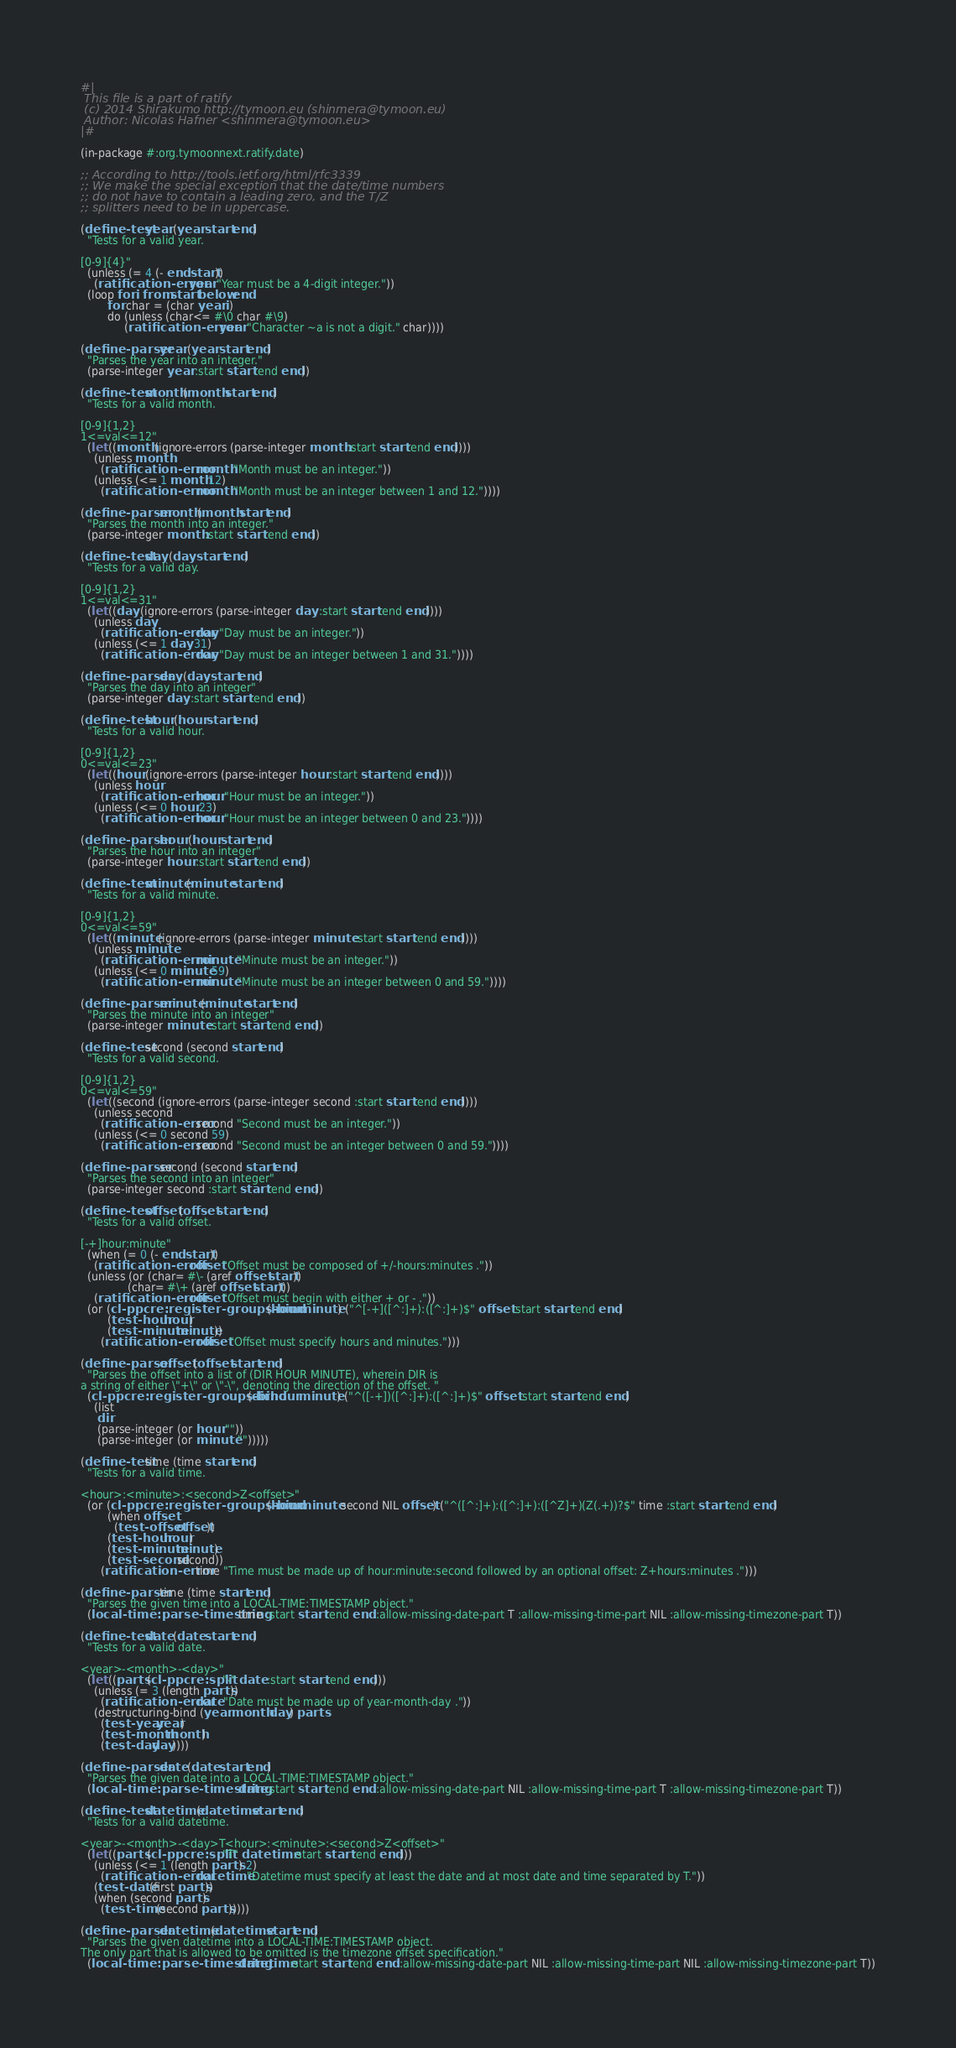Convert code to text. <code><loc_0><loc_0><loc_500><loc_500><_Lisp_>#|
 This file is a part of ratify
 (c) 2014 Shirakumo http://tymoon.eu (shinmera@tymoon.eu)
 Author: Nicolas Hafner <shinmera@tymoon.eu>
|#

(in-package #:org.tymoonnext.ratify.date)

;; According to http://tools.ietf.org/html/rfc3339
;; We make the special exception that the date/time numbers
;; do not have to contain a leading zero, and the T/Z
;; splitters need to be in uppercase.

(define-test year (year start end)
  "Tests for a valid year. 

[0-9]{4}"
  (unless (= 4 (- end start))
    (ratification-error year "Year must be a 4-digit integer."))
  (loop for i from start below end
        for char = (char year i)
        do (unless (char<= #\0 char #\9)
             (ratification-error year "Character ~a is not a digit." char))))

(define-parser year (year start end)
  "Parses the year into an integer."
  (parse-integer year :start start :end end))

(define-test month (month start end)
  "Tests for a valid month.

[0-9]{1,2}
1<=val<=12"
  (let ((month (ignore-errors (parse-integer month :start start :end end))))
    (unless month
      (ratification-error month "Month must be an integer."))
    (unless (<= 1 month 12)
      (ratification-error month "Month must be an integer between 1 and 12."))))

(define-parser month (month start end)
  "Parses the month into an integer."
  (parse-integer month :start start :end end))

(define-test day (day start end)
  "Tests for a valid day.

[0-9]{1,2}
1<=val<=31"
  (let ((day (ignore-errors (parse-integer day :start start :end end))))
    (unless day
      (ratification-error day "Day must be an integer."))
    (unless (<= 1 day 31)
      (ratification-error day "Day must be an integer between 1 and 31."))))

(define-parser day (day start end)
  "Parses the day into an integer"
  (parse-integer day :start start :end end))

(define-test hour (hour start end)
  "Tests for a valid hour.

[0-9]{1,2}
0<=val<=23"
  (let ((hour (ignore-errors (parse-integer hour :start start :end end))))
    (unless hour
      (ratification-error hour "Hour must be an integer."))
    (unless (<= 0 hour 23)
      (ratification-error hour "Hour must be an integer between 0 and 23."))))

(define-parser hour (hour start end)
  "Parses the hour into an integer"
  (parse-integer hour :start start :end end))

(define-test minute (minute start end)
  "Tests for a valid minute.

[0-9]{1,2}
0<=val<=59"
  (let ((minute (ignore-errors (parse-integer minute :start start :end end))))
    (unless minute
      (ratification-error minute "Minute must be an integer."))
    (unless (<= 0 minute 59)
      (ratification-error minute "Minute must be an integer between 0 and 59."))))

(define-parser minute (minute start end)
  "Parses the minute into an integer"
  (parse-integer minute :start start :end end))

(define-test second (second start end)
  "Tests for a valid second.

[0-9]{1,2}
0<=val<=59"
  (let ((second (ignore-errors (parse-integer second :start start :end end))))
    (unless second
      (ratification-error second "Second must be an integer."))
    (unless (<= 0 second 59)
      (ratification-error second "Second must be an integer between 0 and 59."))))

(define-parser second (second start end)
  "Parses the second into an integer"
  (parse-integer second :start start :end end))

(define-test offset (offset start end)
  "Tests for a valid offset.

[-+]hour:minute"
  (when (= 0 (- end start))
    (ratification-error offset "Offset must be composed of +/-hours:minutes ."))
  (unless (or (char= #\- (aref offset start))
              (char= #\+ (aref offset start)))
    (ratification-error offset "Offset must begin with either + or - ."))
  (or (cl-ppcre:register-groups-bind (hour minute) ("^[-+]([^:]+):([^:]+)$" offset :start start :end end)
        (test-hour hour)
        (test-minute minute))
      (ratification-error offset "Offset must specify hours and minutes.")))

(define-parser offset (offset start end)
  "Parses the offset into a list of (DIR HOUR MINUTE), wherein DIR is 
a string of either \"+\" or \"-\", denoting the direction of the offset. "
  (cl-ppcre:register-groups-bind (dir hour minute) ("^([-+])([^:]+):([^:]+)$" offset :start start :end end)
    (list
     dir
     (parse-integer (or hour ""))
     (parse-integer (or minute "")))))

(define-test time (time start end)
  "Tests for a valid time.

<hour>:<minute>:<second>Z<offset>"
  (or (cl-ppcre:register-groups-bind (hour minute second NIL offset) ("^([^:]+):([^:]+):([^Z]+)(Z(.+))?$" time :start start :end end)
        (when offset
          (test-offset offset))
        (test-hour hour)
        (test-minute minute)
        (test-second second))
      (ratification-error time "Time must be made up of hour:minute:second followed by an optional offset: Z+hours:minutes .")))

(define-parser time (time start end)
  "Parses the given time into a LOCAL-TIME:TIMESTAMP object."
  (local-time:parse-timestring time :start start :end end :allow-missing-date-part T :allow-missing-time-part NIL :allow-missing-timezone-part T))

(define-test date (date start end)
  "Tests for a valid date.

<year>-<month>-<day>"
  (let ((parts (cl-ppcre:split "-" date :start start :end end)))
    (unless (= 3 (length parts))
      (ratification-error date "Date must be made up of year-month-day ."))
    (destructuring-bind (year month day) parts
      (test-year year)
      (test-month month)
      (test-day day))))

(define-parser date (date start end)
  "Parses the given date into a LOCAL-TIME:TIMESTAMP object."
  (local-time:parse-timestring date :start start :end end :allow-missing-date-part NIL :allow-missing-time-part T :allow-missing-timezone-part T))

(define-test datetime (datetime start end)
  "Tests for a valid datetime.

<year>-<month>-<day>T<hour>:<minute>:<second>Z<offset>"
  (let ((parts (cl-ppcre:split "T" datetime :start start :end end)))
    (unless (<= 1 (length parts) 2)
      (ratification-error datetime "Datetime must specify at least the date and at most date and time separated by T."))
    (test-date (first parts))
    (when (second parts)
      (test-time (second parts)))))

(define-parser datetime (datetime start end)
  "Parses the given datetime into a LOCAL-TIME:TIMESTAMP object.
The only part that is allowed to be omitted is the timezone offset specification."
  (local-time:parse-timestring datetime :start start :end end :allow-missing-date-part NIL :allow-missing-time-part NIL :allow-missing-timezone-part T))
</code> 